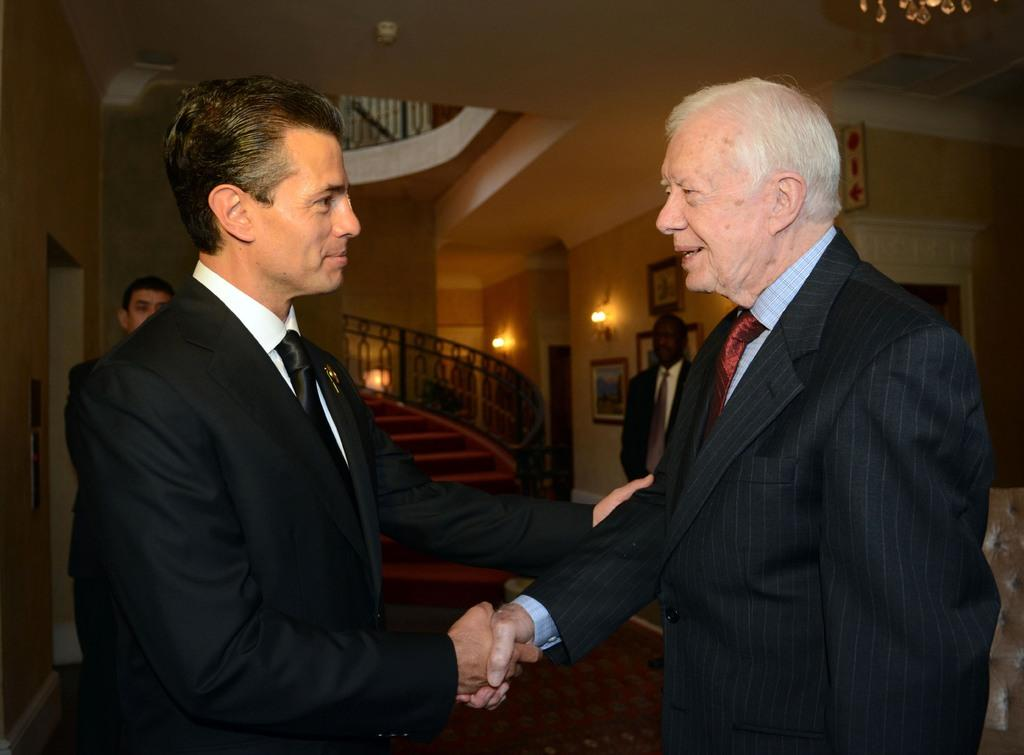How many men are present in the image? There are four men in the image. What are two of the men doing in the image? Two of the men are shaking hands. What is the facial expression of the men in the image? The men are smiling. What can be seen in the background of the image? There are steps, lights, and frames on the wall in the background of the image. Can you see a tiger in the image? No, there is no tiger present in the image. What is the level of the chin of the man on the left? There is no specific mention of the chin of any man in the image, and therefore we cannot determine the level of any chin. 